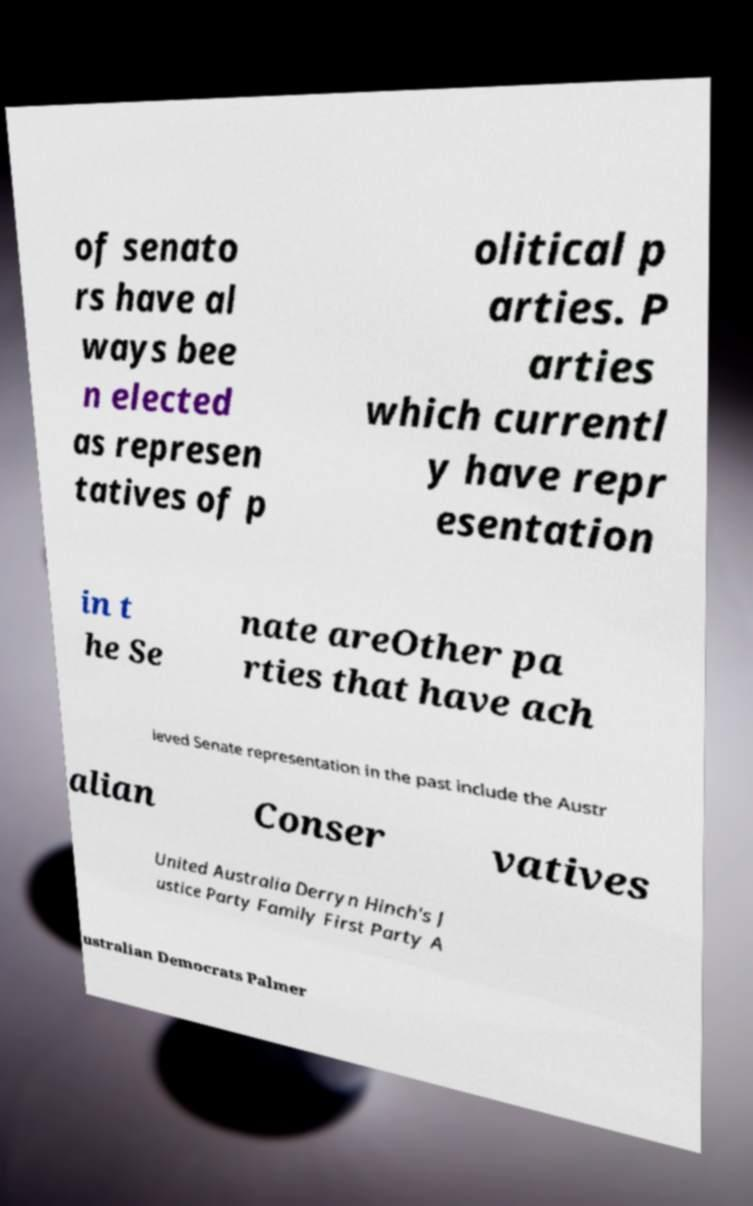Could you extract and type out the text from this image? of senato rs have al ways bee n elected as represen tatives of p olitical p arties. P arties which currentl y have repr esentation in t he Se nate areOther pa rties that have ach ieved Senate representation in the past include the Austr alian Conser vatives United Australia Derryn Hinch's J ustice Party Family First Party A ustralian Democrats Palmer 